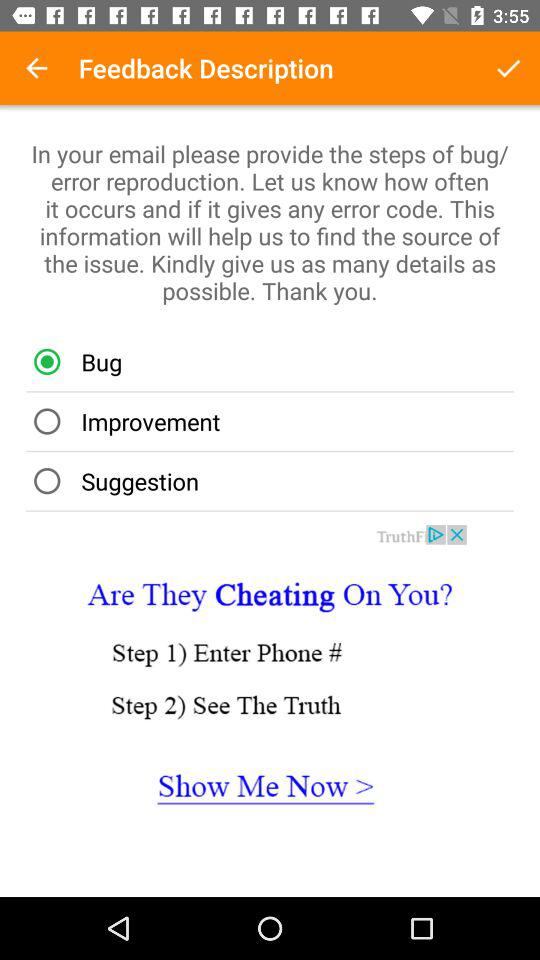Which option is selected? The selected option is "Bug". 